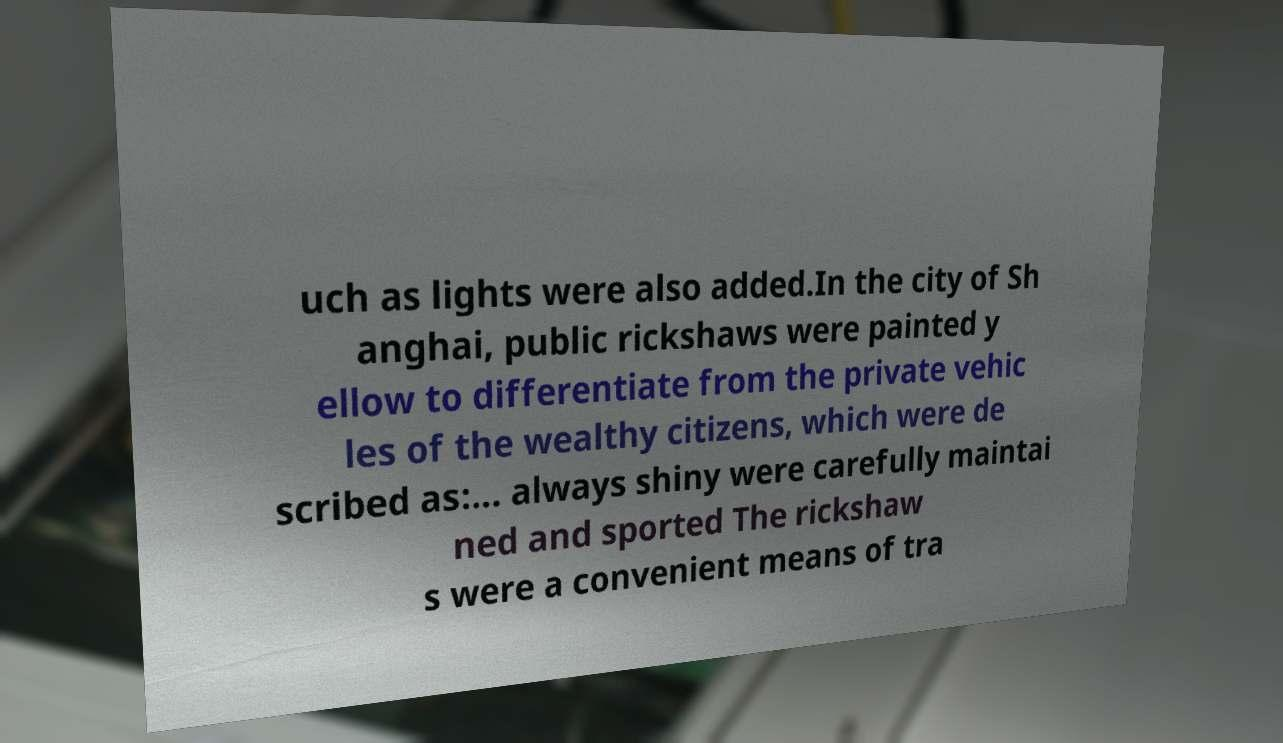Please identify and transcribe the text found in this image. uch as lights were also added.In the city of Sh anghai, public rickshaws were painted y ellow to differentiate from the private vehic les of the wealthy citizens, which were de scribed as:... always shiny were carefully maintai ned and sported The rickshaw s were a convenient means of tra 